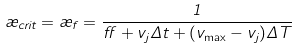<formula> <loc_0><loc_0><loc_500><loc_500>\rho _ { c r i t } = \rho _ { f } = \frac { 1 } { \alpha + v _ { j } \Delta t + ( v _ { \max } - v _ { j } ) \Delta T }</formula> 